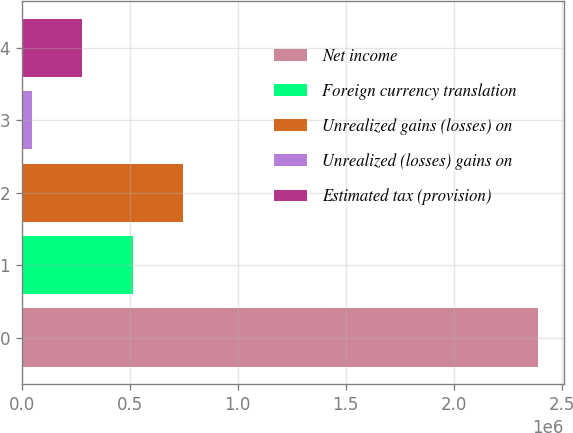Convert chart to OTSL. <chart><loc_0><loc_0><loc_500><loc_500><bar_chart><fcel>Net income<fcel>Foreign currency translation<fcel>Unrealized gains (losses) on<fcel>Unrealized (losses) gains on<fcel>Estimated tax (provision)<nl><fcel>2.3891e+06<fcel>513958<fcel>748350<fcel>45173<fcel>279565<nl></chart> 